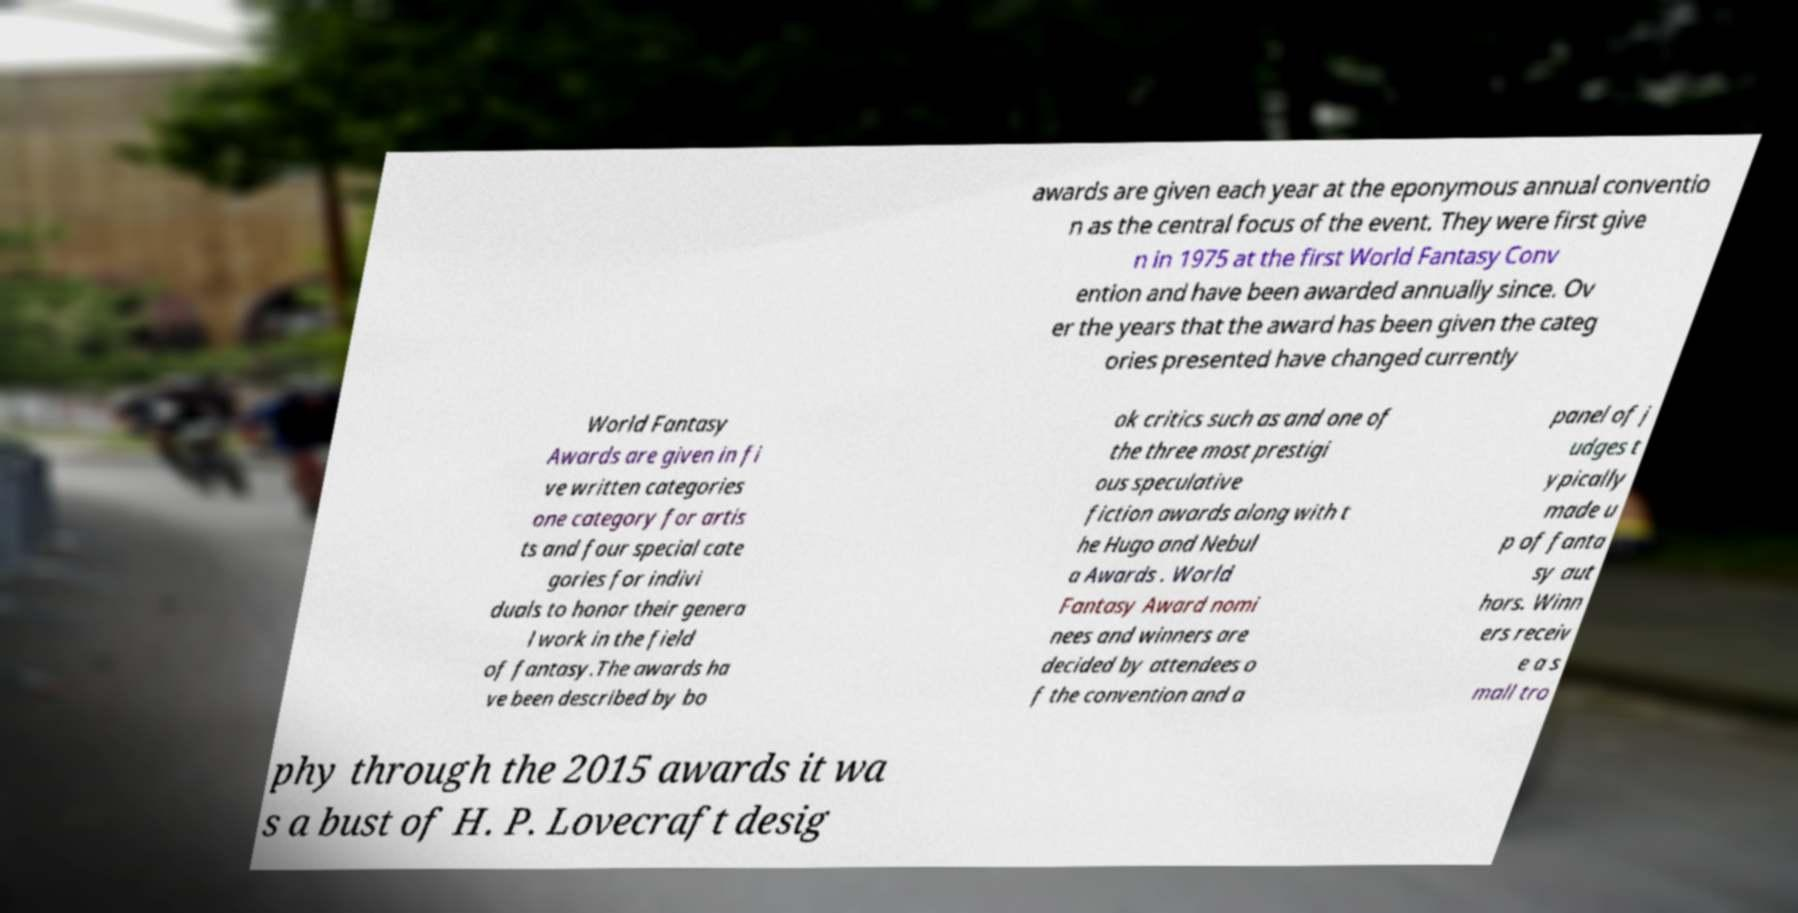Can you read and provide the text displayed in the image?This photo seems to have some interesting text. Can you extract and type it out for me? awards are given each year at the eponymous annual conventio n as the central focus of the event. They were first give n in 1975 at the first World Fantasy Conv ention and have been awarded annually since. Ov er the years that the award has been given the categ ories presented have changed currently World Fantasy Awards are given in fi ve written categories one category for artis ts and four special cate gories for indivi duals to honor their genera l work in the field of fantasy.The awards ha ve been described by bo ok critics such as and one of the three most prestigi ous speculative fiction awards along with t he Hugo and Nebul a Awards . World Fantasy Award nomi nees and winners are decided by attendees o f the convention and a panel of j udges t ypically made u p of fanta sy aut hors. Winn ers receiv e a s mall tro phy through the 2015 awards it wa s a bust of H. P. Lovecraft desig 